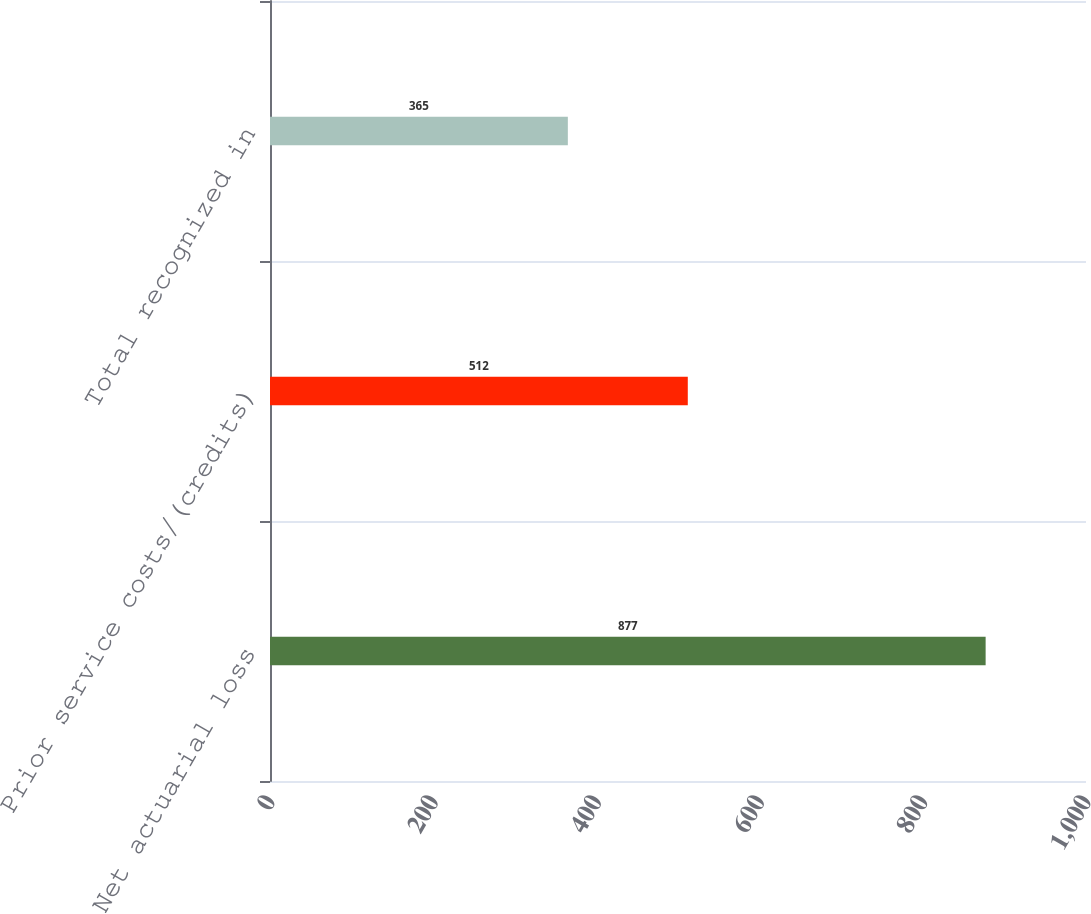<chart> <loc_0><loc_0><loc_500><loc_500><bar_chart><fcel>Net actuarial loss<fcel>Prior service costs/(credits)<fcel>Total recognized in<nl><fcel>877<fcel>512<fcel>365<nl></chart> 